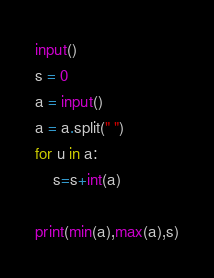<code> <loc_0><loc_0><loc_500><loc_500><_Python_>
input()
s = 0
a = input()
a = a.split(" ")
for u in a:
    s=s+int(a)

print(min(a),max(a),s)
</code> 